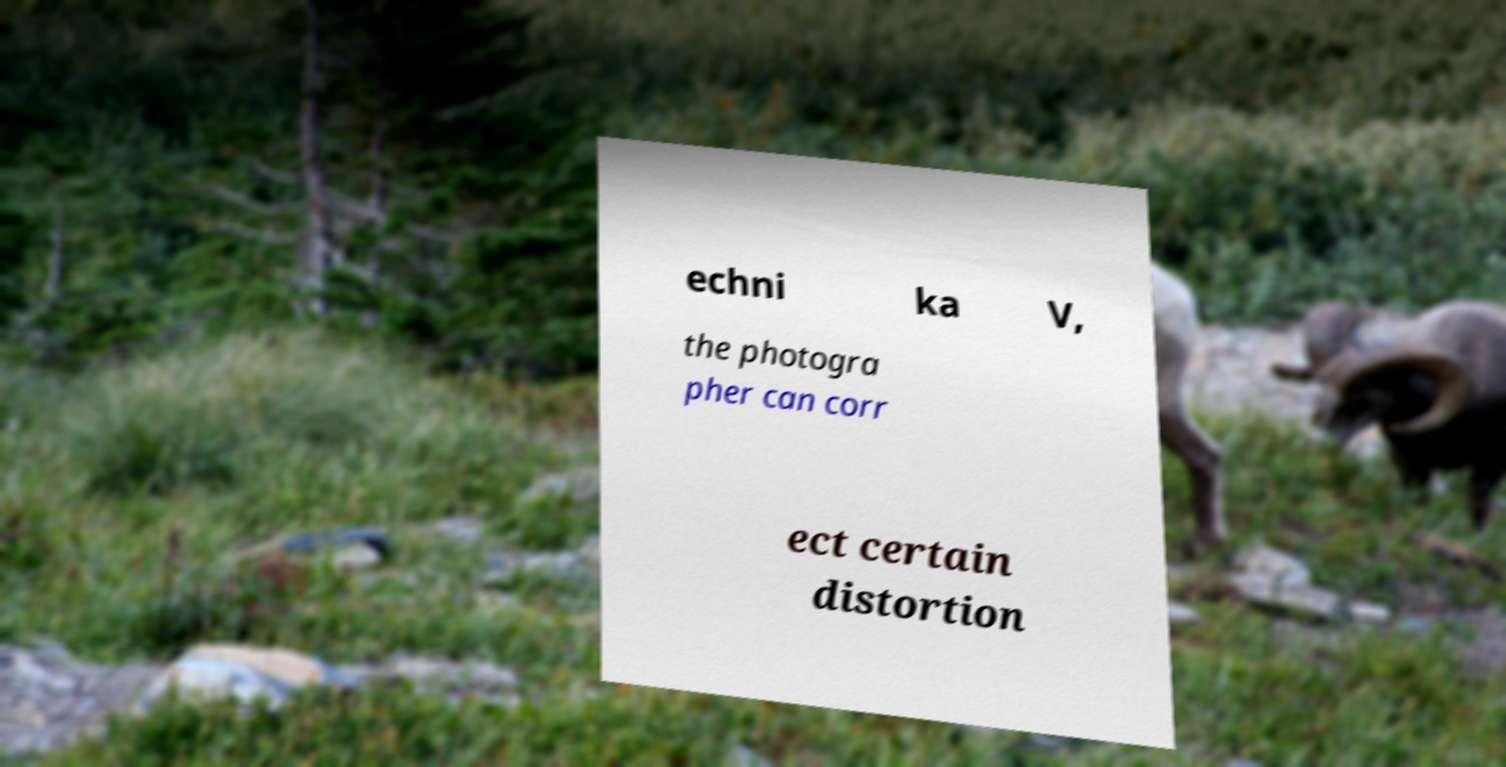Could you assist in decoding the text presented in this image and type it out clearly? echni ka V, the photogra pher can corr ect certain distortion 